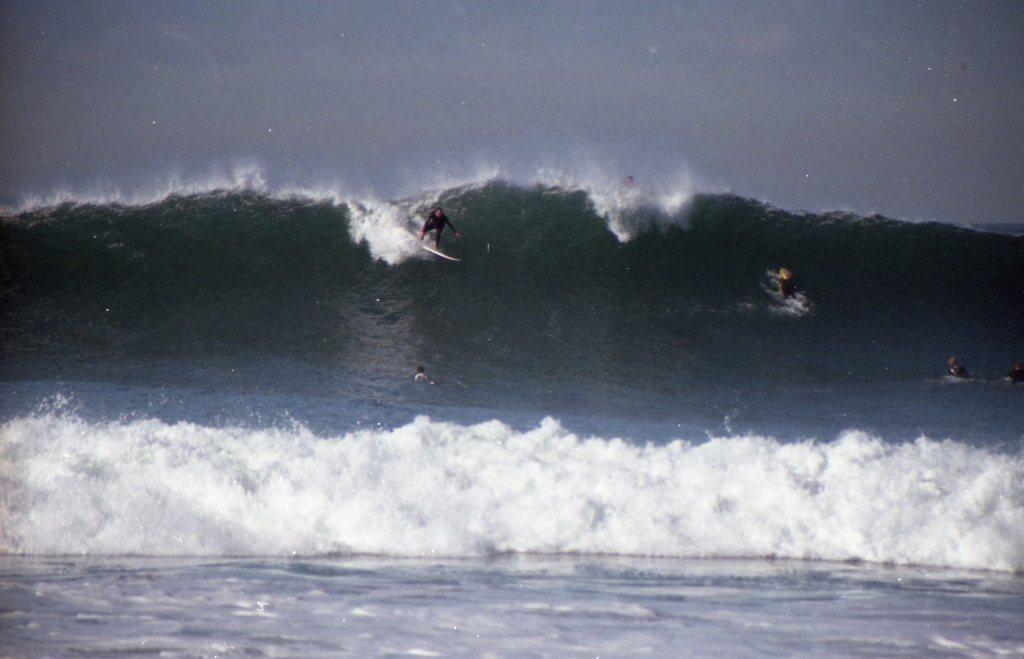What is the person in the image doing? The person is surfing in the image. Where is the person surfing? The person is in the sea. What can be seen at the top of the image? The sky is visible at the top of the image. How many hearts can be seen beating in the image? There are no hearts visible in the image; it features a person surfing in the sea. Can you describe the person's head in the image? There is no specific detail about the person's head mentioned in the provided facts, so it cannot be described. 